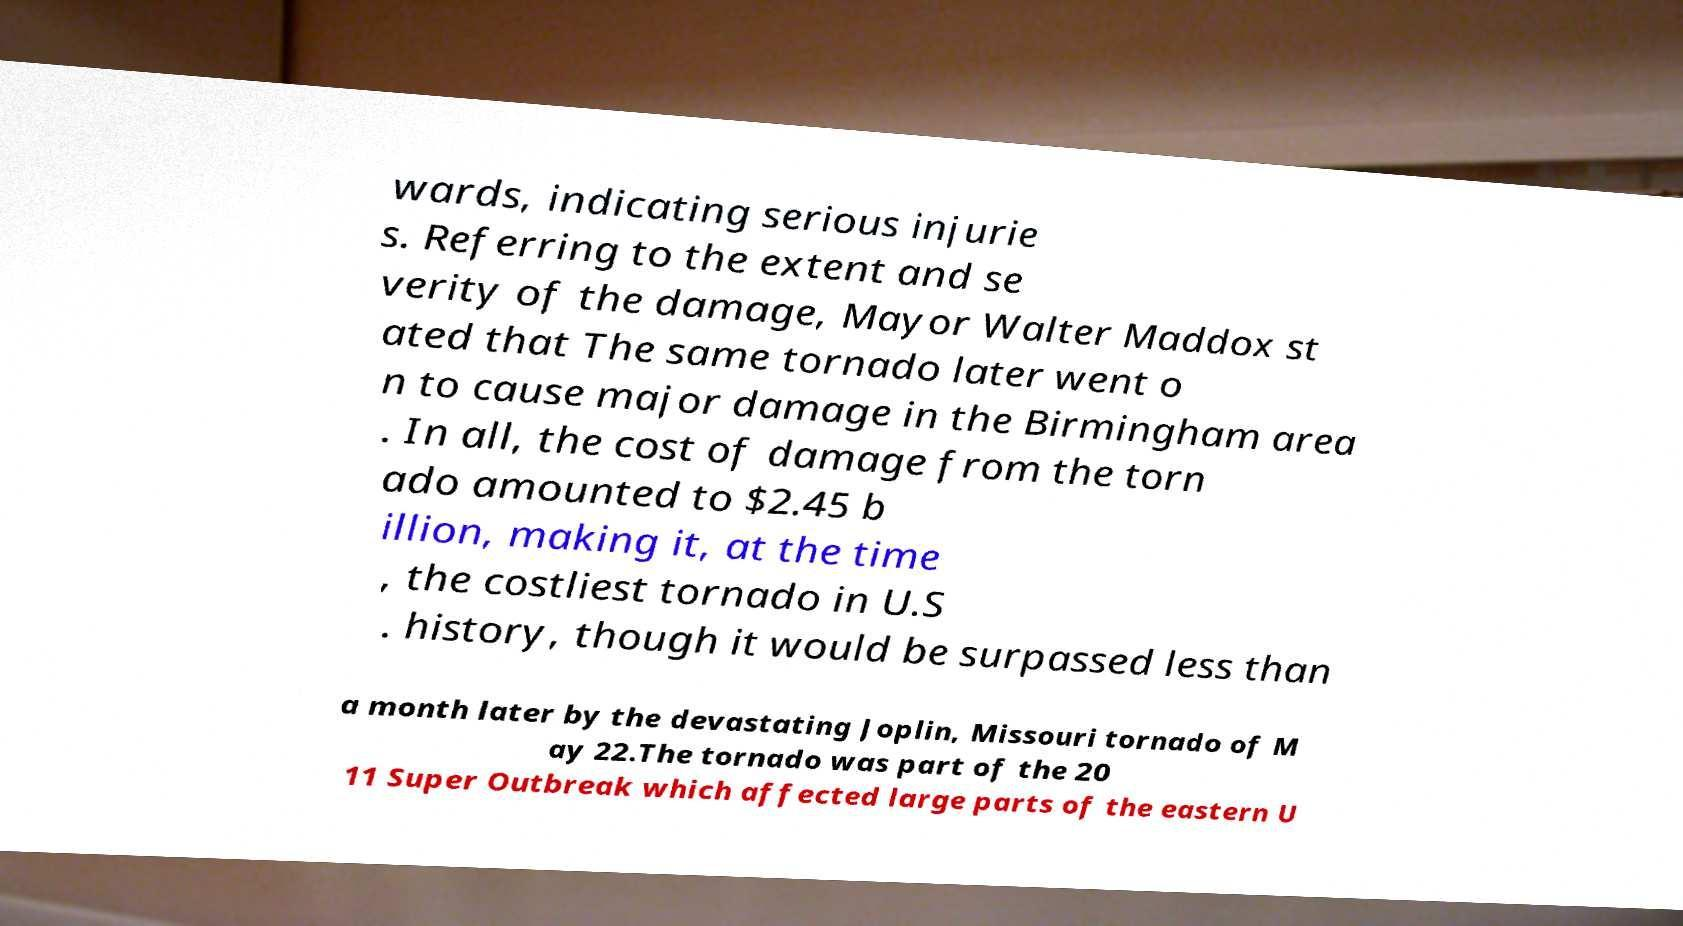I need the written content from this picture converted into text. Can you do that? wards, indicating serious injurie s. Referring to the extent and se verity of the damage, Mayor Walter Maddox st ated that The same tornado later went o n to cause major damage in the Birmingham area . In all, the cost of damage from the torn ado amounted to $2.45 b illion, making it, at the time , the costliest tornado in U.S . history, though it would be surpassed less than a month later by the devastating Joplin, Missouri tornado of M ay 22.The tornado was part of the 20 11 Super Outbreak which affected large parts of the eastern U 